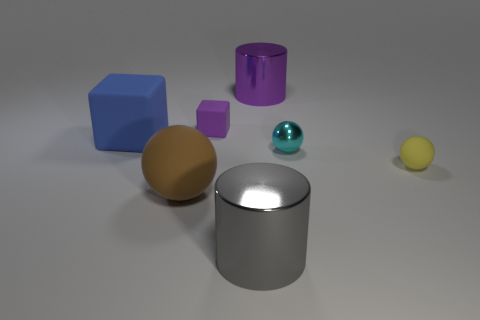The other metal object that is the same size as the yellow object is what color?
Your answer should be very brief. Cyan. Are there any cylinders that have the same color as the tiny block?
Your response must be concise. Yes. Is there a small purple metal cylinder?
Your answer should be very brief. No. Do the ball on the left side of the tiny purple rubber object and the large gray object have the same material?
Provide a succinct answer. No. How many rubber cubes are the same size as the brown rubber sphere?
Offer a terse response. 1. Are there an equal number of gray objects behind the purple matte thing and brown cylinders?
Ensure brevity in your answer.  Yes. What number of things are behind the tiny cyan ball and to the right of the large rubber ball?
Your answer should be very brief. 2. The cyan thing that is made of the same material as the large purple cylinder is what size?
Make the answer very short. Small. How many other objects are the same shape as the blue rubber object?
Ensure brevity in your answer.  1. Is the number of small cyan objects that are in front of the purple rubber object greater than the number of small cylinders?
Ensure brevity in your answer.  Yes. 